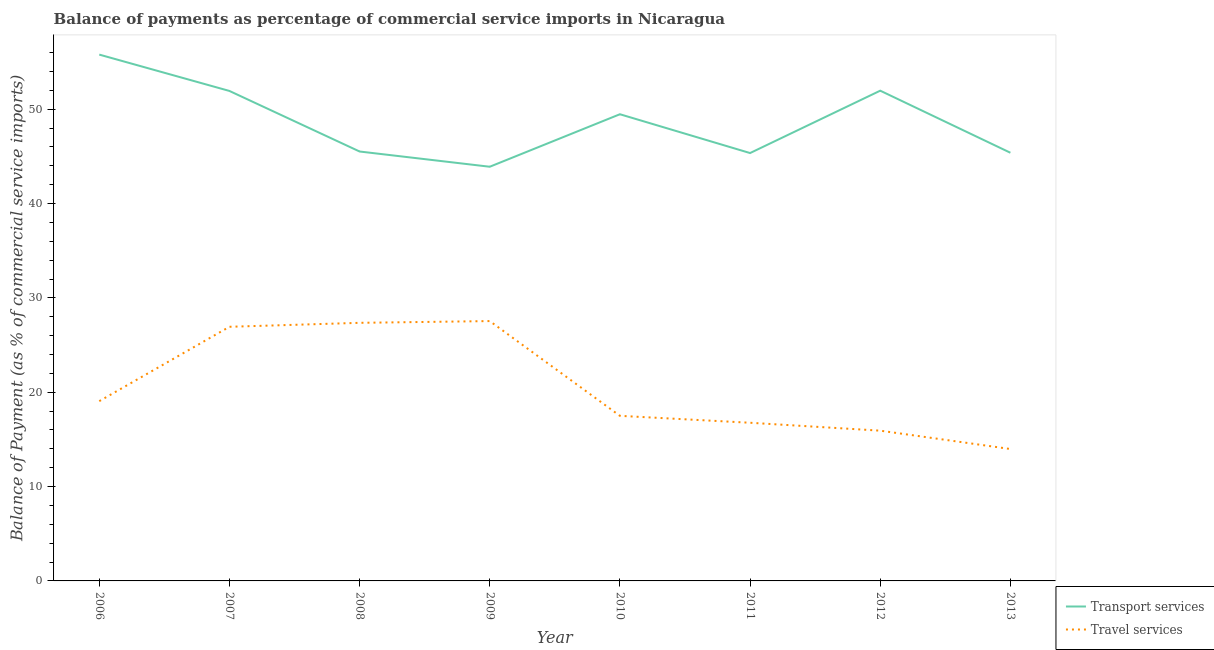How many different coloured lines are there?
Provide a short and direct response. 2. Is the number of lines equal to the number of legend labels?
Provide a succinct answer. Yes. What is the balance of payments of travel services in 2013?
Keep it short and to the point. 13.98. Across all years, what is the maximum balance of payments of transport services?
Your response must be concise. 55.78. Across all years, what is the minimum balance of payments of travel services?
Ensure brevity in your answer.  13.98. In which year was the balance of payments of travel services minimum?
Offer a terse response. 2013. What is the total balance of payments of transport services in the graph?
Provide a short and direct response. 389.28. What is the difference between the balance of payments of travel services in 2011 and that in 2013?
Provide a short and direct response. 2.78. What is the difference between the balance of payments of transport services in 2007 and the balance of payments of travel services in 2006?
Your answer should be very brief. 32.88. What is the average balance of payments of travel services per year?
Offer a very short reply. 20.63. In the year 2012, what is the difference between the balance of payments of travel services and balance of payments of transport services?
Keep it short and to the point. -36.03. What is the ratio of the balance of payments of transport services in 2009 to that in 2013?
Your response must be concise. 0.97. Is the difference between the balance of payments of transport services in 2008 and 2010 greater than the difference between the balance of payments of travel services in 2008 and 2010?
Keep it short and to the point. No. What is the difference between the highest and the second highest balance of payments of transport services?
Your answer should be very brief. 3.82. What is the difference between the highest and the lowest balance of payments of travel services?
Provide a short and direct response. 13.56. Is the sum of the balance of payments of travel services in 2009 and 2012 greater than the maximum balance of payments of transport services across all years?
Make the answer very short. No. Does the balance of payments of travel services monotonically increase over the years?
Offer a very short reply. No. How many years are there in the graph?
Your answer should be compact. 8. What is the difference between two consecutive major ticks on the Y-axis?
Offer a very short reply. 10. Does the graph contain any zero values?
Give a very brief answer. No. Does the graph contain grids?
Your answer should be very brief. No. How many legend labels are there?
Your response must be concise. 2. What is the title of the graph?
Offer a very short reply. Balance of payments as percentage of commercial service imports in Nicaragua. What is the label or title of the X-axis?
Keep it short and to the point. Year. What is the label or title of the Y-axis?
Your response must be concise. Balance of Payment (as % of commercial service imports). What is the Balance of Payment (as % of commercial service imports) of Transport services in 2006?
Ensure brevity in your answer.  55.78. What is the Balance of Payment (as % of commercial service imports) in Travel services in 2006?
Offer a terse response. 19.05. What is the Balance of Payment (as % of commercial service imports) of Transport services in 2007?
Offer a terse response. 51.93. What is the Balance of Payment (as % of commercial service imports) of Travel services in 2007?
Ensure brevity in your answer.  26.94. What is the Balance of Payment (as % of commercial service imports) in Transport services in 2008?
Make the answer very short. 45.51. What is the Balance of Payment (as % of commercial service imports) of Travel services in 2008?
Your response must be concise. 27.36. What is the Balance of Payment (as % of commercial service imports) of Transport services in 2009?
Offer a very short reply. 43.9. What is the Balance of Payment (as % of commercial service imports) of Travel services in 2009?
Your answer should be compact. 27.54. What is the Balance of Payment (as % of commercial service imports) of Transport services in 2010?
Give a very brief answer. 49.46. What is the Balance of Payment (as % of commercial service imports) of Travel services in 2010?
Ensure brevity in your answer.  17.5. What is the Balance of Payment (as % of commercial service imports) in Transport services in 2011?
Make the answer very short. 45.35. What is the Balance of Payment (as % of commercial service imports) in Travel services in 2011?
Give a very brief answer. 16.76. What is the Balance of Payment (as % of commercial service imports) in Transport services in 2012?
Your response must be concise. 51.96. What is the Balance of Payment (as % of commercial service imports) in Travel services in 2012?
Your response must be concise. 15.93. What is the Balance of Payment (as % of commercial service imports) of Transport services in 2013?
Provide a short and direct response. 45.38. What is the Balance of Payment (as % of commercial service imports) in Travel services in 2013?
Your response must be concise. 13.98. Across all years, what is the maximum Balance of Payment (as % of commercial service imports) of Transport services?
Your response must be concise. 55.78. Across all years, what is the maximum Balance of Payment (as % of commercial service imports) in Travel services?
Provide a short and direct response. 27.54. Across all years, what is the minimum Balance of Payment (as % of commercial service imports) of Transport services?
Your answer should be compact. 43.9. Across all years, what is the minimum Balance of Payment (as % of commercial service imports) of Travel services?
Give a very brief answer. 13.98. What is the total Balance of Payment (as % of commercial service imports) of Transport services in the graph?
Provide a short and direct response. 389.28. What is the total Balance of Payment (as % of commercial service imports) in Travel services in the graph?
Offer a terse response. 165.05. What is the difference between the Balance of Payment (as % of commercial service imports) of Transport services in 2006 and that in 2007?
Provide a short and direct response. 3.85. What is the difference between the Balance of Payment (as % of commercial service imports) in Travel services in 2006 and that in 2007?
Ensure brevity in your answer.  -7.88. What is the difference between the Balance of Payment (as % of commercial service imports) in Transport services in 2006 and that in 2008?
Your answer should be very brief. 10.27. What is the difference between the Balance of Payment (as % of commercial service imports) of Travel services in 2006 and that in 2008?
Give a very brief answer. -8.3. What is the difference between the Balance of Payment (as % of commercial service imports) of Transport services in 2006 and that in 2009?
Your answer should be compact. 11.89. What is the difference between the Balance of Payment (as % of commercial service imports) in Travel services in 2006 and that in 2009?
Offer a terse response. -8.49. What is the difference between the Balance of Payment (as % of commercial service imports) of Transport services in 2006 and that in 2010?
Your answer should be compact. 6.32. What is the difference between the Balance of Payment (as % of commercial service imports) of Travel services in 2006 and that in 2010?
Keep it short and to the point. 1.56. What is the difference between the Balance of Payment (as % of commercial service imports) of Transport services in 2006 and that in 2011?
Provide a short and direct response. 10.44. What is the difference between the Balance of Payment (as % of commercial service imports) in Travel services in 2006 and that in 2011?
Offer a terse response. 2.29. What is the difference between the Balance of Payment (as % of commercial service imports) of Transport services in 2006 and that in 2012?
Your answer should be very brief. 3.82. What is the difference between the Balance of Payment (as % of commercial service imports) in Travel services in 2006 and that in 2012?
Ensure brevity in your answer.  3.13. What is the difference between the Balance of Payment (as % of commercial service imports) in Transport services in 2006 and that in 2013?
Offer a terse response. 10.4. What is the difference between the Balance of Payment (as % of commercial service imports) in Travel services in 2006 and that in 2013?
Keep it short and to the point. 5.07. What is the difference between the Balance of Payment (as % of commercial service imports) in Transport services in 2007 and that in 2008?
Your answer should be very brief. 6.42. What is the difference between the Balance of Payment (as % of commercial service imports) in Travel services in 2007 and that in 2008?
Keep it short and to the point. -0.42. What is the difference between the Balance of Payment (as % of commercial service imports) in Transport services in 2007 and that in 2009?
Make the answer very short. 8.03. What is the difference between the Balance of Payment (as % of commercial service imports) in Travel services in 2007 and that in 2009?
Provide a succinct answer. -0.61. What is the difference between the Balance of Payment (as % of commercial service imports) in Transport services in 2007 and that in 2010?
Give a very brief answer. 2.47. What is the difference between the Balance of Payment (as % of commercial service imports) of Travel services in 2007 and that in 2010?
Provide a short and direct response. 9.44. What is the difference between the Balance of Payment (as % of commercial service imports) of Transport services in 2007 and that in 2011?
Offer a terse response. 6.58. What is the difference between the Balance of Payment (as % of commercial service imports) of Travel services in 2007 and that in 2011?
Ensure brevity in your answer.  10.17. What is the difference between the Balance of Payment (as % of commercial service imports) in Transport services in 2007 and that in 2012?
Make the answer very short. -0.03. What is the difference between the Balance of Payment (as % of commercial service imports) in Travel services in 2007 and that in 2012?
Give a very brief answer. 11.01. What is the difference between the Balance of Payment (as % of commercial service imports) in Transport services in 2007 and that in 2013?
Give a very brief answer. 6.55. What is the difference between the Balance of Payment (as % of commercial service imports) in Travel services in 2007 and that in 2013?
Your answer should be very brief. 12.95. What is the difference between the Balance of Payment (as % of commercial service imports) in Transport services in 2008 and that in 2009?
Keep it short and to the point. 1.62. What is the difference between the Balance of Payment (as % of commercial service imports) of Travel services in 2008 and that in 2009?
Offer a terse response. -0.19. What is the difference between the Balance of Payment (as % of commercial service imports) in Transport services in 2008 and that in 2010?
Provide a short and direct response. -3.95. What is the difference between the Balance of Payment (as % of commercial service imports) of Travel services in 2008 and that in 2010?
Give a very brief answer. 9.86. What is the difference between the Balance of Payment (as % of commercial service imports) of Transport services in 2008 and that in 2011?
Give a very brief answer. 0.16. What is the difference between the Balance of Payment (as % of commercial service imports) of Travel services in 2008 and that in 2011?
Your response must be concise. 10.59. What is the difference between the Balance of Payment (as % of commercial service imports) in Transport services in 2008 and that in 2012?
Your response must be concise. -6.45. What is the difference between the Balance of Payment (as % of commercial service imports) of Travel services in 2008 and that in 2012?
Make the answer very short. 11.43. What is the difference between the Balance of Payment (as % of commercial service imports) of Transport services in 2008 and that in 2013?
Your answer should be compact. 0.13. What is the difference between the Balance of Payment (as % of commercial service imports) of Travel services in 2008 and that in 2013?
Your response must be concise. 13.37. What is the difference between the Balance of Payment (as % of commercial service imports) of Transport services in 2009 and that in 2010?
Your answer should be very brief. -5.57. What is the difference between the Balance of Payment (as % of commercial service imports) of Travel services in 2009 and that in 2010?
Your answer should be very brief. 10.04. What is the difference between the Balance of Payment (as % of commercial service imports) in Transport services in 2009 and that in 2011?
Your answer should be very brief. -1.45. What is the difference between the Balance of Payment (as % of commercial service imports) of Travel services in 2009 and that in 2011?
Keep it short and to the point. 10.78. What is the difference between the Balance of Payment (as % of commercial service imports) in Transport services in 2009 and that in 2012?
Provide a short and direct response. -8.06. What is the difference between the Balance of Payment (as % of commercial service imports) of Travel services in 2009 and that in 2012?
Offer a very short reply. 11.62. What is the difference between the Balance of Payment (as % of commercial service imports) in Transport services in 2009 and that in 2013?
Ensure brevity in your answer.  -1.48. What is the difference between the Balance of Payment (as % of commercial service imports) in Travel services in 2009 and that in 2013?
Your response must be concise. 13.56. What is the difference between the Balance of Payment (as % of commercial service imports) of Transport services in 2010 and that in 2011?
Ensure brevity in your answer.  4.11. What is the difference between the Balance of Payment (as % of commercial service imports) of Travel services in 2010 and that in 2011?
Your answer should be very brief. 0.73. What is the difference between the Balance of Payment (as % of commercial service imports) of Transport services in 2010 and that in 2012?
Offer a very short reply. -2.5. What is the difference between the Balance of Payment (as % of commercial service imports) of Travel services in 2010 and that in 2012?
Make the answer very short. 1.57. What is the difference between the Balance of Payment (as % of commercial service imports) of Transport services in 2010 and that in 2013?
Offer a terse response. 4.08. What is the difference between the Balance of Payment (as % of commercial service imports) of Travel services in 2010 and that in 2013?
Offer a terse response. 3.52. What is the difference between the Balance of Payment (as % of commercial service imports) of Transport services in 2011 and that in 2012?
Keep it short and to the point. -6.61. What is the difference between the Balance of Payment (as % of commercial service imports) in Travel services in 2011 and that in 2012?
Make the answer very short. 0.84. What is the difference between the Balance of Payment (as % of commercial service imports) in Transport services in 2011 and that in 2013?
Provide a short and direct response. -0.03. What is the difference between the Balance of Payment (as % of commercial service imports) of Travel services in 2011 and that in 2013?
Provide a succinct answer. 2.78. What is the difference between the Balance of Payment (as % of commercial service imports) in Transport services in 2012 and that in 2013?
Offer a very short reply. 6.58. What is the difference between the Balance of Payment (as % of commercial service imports) of Travel services in 2012 and that in 2013?
Your response must be concise. 1.94. What is the difference between the Balance of Payment (as % of commercial service imports) of Transport services in 2006 and the Balance of Payment (as % of commercial service imports) of Travel services in 2007?
Ensure brevity in your answer.  28.85. What is the difference between the Balance of Payment (as % of commercial service imports) in Transport services in 2006 and the Balance of Payment (as % of commercial service imports) in Travel services in 2008?
Offer a terse response. 28.43. What is the difference between the Balance of Payment (as % of commercial service imports) in Transport services in 2006 and the Balance of Payment (as % of commercial service imports) in Travel services in 2009?
Keep it short and to the point. 28.24. What is the difference between the Balance of Payment (as % of commercial service imports) of Transport services in 2006 and the Balance of Payment (as % of commercial service imports) of Travel services in 2010?
Give a very brief answer. 38.29. What is the difference between the Balance of Payment (as % of commercial service imports) in Transport services in 2006 and the Balance of Payment (as % of commercial service imports) in Travel services in 2011?
Your answer should be compact. 39.02. What is the difference between the Balance of Payment (as % of commercial service imports) of Transport services in 2006 and the Balance of Payment (as % of commercial service imports) of Travel services in 2012?
Provide a succinct answer. 39.86. What is the difference between the Balance of Payment (as % of commercial service imports) of Transport services in 2006 and the Balance of Payment (as % of commercial service imports) of Travel services in 2013?
Offer a very short reply. 41.8. What is the difference between the Balance of Payment (as % of commercial service imports) in Transport services in 2007 and the Balance of Payment (as % of commercial service imports) in Travel services in 2008?
Your answer should be compact. 24.58. What is the difference between the Balance of Payment (as % of commercial service imports) in Transport services in 2007 and the Balance of Payment (as % of commercial service imports) in Travel services in 2009?
Your answer should be compact. 24.39. What is the difference between the Balance of Payment (as % of commercial service imports) of Transport services in 2007 and the Balance of Payment (as % of commercial service imports) of Travel services in 2010?
Your answer should be compact. 34.43. What is the difference between the Balance of Payment (as % of commercial service imports) in Transport services in 2007 and the Balance of Payment (as % of commercial service imports) in Travel services in 2011?
Ensure brevity in your answer.  35.17. What is the difference between the Balance of Payment (as % of commercial service imports) in Transport services in 2007 and the Balance of Payment (as % of commercial service imports) in Travel services in 2012?
Give a very brief answer. 36.01. What is the difference between the Balance of Payment (as % of commercial service imports) in Transport services in 2007 and the Balance of Payment (as % of commercial service imports) in Travel services in 2013?
Provide a short and direct response. 37.95. What is the difference between the Balance of Payment (as % of commercial service imports) of Transport services in 2008 and the Balance of Payment (as % of commercial service imports) of Travel services in 2009?
Your answer should be compact. 17.97. What is the difference between the Balance of Payment (as % of commercial service imports) in Transport services in 2008 and the Balance of Payment (as % of commercial service imports) in Travel services in 2010?
Make the answer very short. 28.02. What is the difference between the Balance of Payment (as % of commercial service imports) in Transport services in 2008 and the Balance of Payment (as % of commercial service imports) in Travel services in 2011?
Your answer should be very brief. 28.75. What is the difference between the Balance of Payment (as % of commercial service imports) in Transport services in 2008 and the Balance of Payment (as % of commercial service imports) in Travel services in 2012?
Give a very brief answer. 29.59. What is the difference between the Balance of Payment (as % of commercial service imports) of Transport services in 2008 and the Balance of Payment (as % of commercial service imports) of Travel services in 2013?
Ensure brevity in your answer.  31.53. What is the difference between the Balance of Payment (as % of commercial service imports) of Transport services in 2009 and the Balance of Payment (as % of commercial service imports) of Travel services in 2010?
Give a very brief answer. 26.4. What is the difference between the Balance of Payment (as % of commercial service imports) of Transport services in 2009 and the Balance of Payment (as % of commercial service imports) of Travel services in 2011?
Make the answer very short. 27.13. What is the difference between the Balance of Payment (as % of commercial service imports) of Transport services in 2009 and the Balance of Payment (as % of commercial service imports) of Travel services in 2012?
Your answer should be compact. 27.97. What is the difference between the Balance of Payment (as % of commercial service imports) of Transport services in 2009 and the Balance of Payment (as % of commercial service imports) of Travel services in 2013?
Provide a short and direct response. 29.92. What is the difference between the Balance of Payment (as % of commercial service imports) in Transport services in 2010 and the Balance of Payment (as % of commercial service imports) in Travel services in 2011?
Give a very brief answer. 32.7. What is the difference between the Balance of Payment (as % of commercial service imports) of Transport services in 2010 and the Balance of Payment (as % of commercial service imports) of Travel services in 2012?
Provide a short and direct response. 33.54. What is the difference between the Balance of Payment (as % of commercial service imports) in Transport services in 2010 and the Balance of Payment (as % of commercial service imports) in Travel services in 2013?
Provide a succinct answer. 35.48. What is the difference between the Balance of Payment (as % of commercial service imports) in Transport services in 2011 and the Balance of Payment (as % of commercial service imports) in Travel services in 2012?
Your answer should be compact. 29.42. What is the difference between the Balance of Payment (as % of commercial service imports) of Transport services in 2011 and the Balance of Payment (as % of commercial service imports) of Travel services in 2013?
Your answer should be very brief. 31.37. What is the difference between the Balance of Payment (as % of commercial service imports) of Transport services in 2012 and the Balance of Payment (as % of commercial service imports) of Travel services in 2013?
Offer a very short reply. 37.98. What is the average Balance of Payment (as % of commercial service imports) in Transport services per year?
Your answer should be compact. 48.66. What is the average Balance of Payment (as % of commercial service imports) of Travel services per year?
Ensure brevity in your answer.  20.63. In the year 2006, what is the difference between the Balance of Payment (as % of commercial service imports) in Transport services and Balance of Payment (as % of commercial service imports) in Travel services?
Your response must be concise. 36.73. In the year 2007, what is the difference between the Balance of Payment (as % of commercial service imports) in Transport services and Balance of Payment (as % of commercial service imports) in Travel services?
Your response must be concise. 25. In the year 2008, what is the difference between the Balance of Payment (as % of commercial service imports) of Transport services and Balance of Payment (as % of commercial service imports) of Travel services?
Provide a succinct answer. 18.16. In the year 2009, what is the difference between the Balance of Payment (as % of commercial service imports) in Transport services and Balance of Payment (as % of commercial service imports) in Travel services?
Offer a very short reply. 16.36. In the year 2010, what is the difference between the Balance of Payment (as % of commercial service imports) of Transport services and Balance of Payment (as % of commercial service imports) of Travel services?
Give a very brief answer. 31.97. In the year 2011, what is the difference between the Balance of Payment (as % of commercial service imports) of Transport services and Balance of Payment (as % of commercial service imports) of Travel services?
Your answer should be very brief. 28.59. In the year 2012, what is the difference between the Balance of Payment (as % of commercial service imports) of Transport services and Balance of Payment (as % of commercial service imports) of Travel services?
Give a very brief answer. 36.03. In the year 2013, what is the difference between the Balance of Payment (as % of commercial service imports) of Transport services and Balance of Payment (as % of commercial service imports) of Travel services?
Keep it short and to the point. 31.4. What is the ratio of the Balance of Payment (as % of commercial service imports) of Transport services in 2006 to that in 2007?
Offer a very short reply. 1.07. What is the ratio of the Balance of Payment (as % of commercial service imports) of Travel services in 2006 to that in 2007?
Give a very brief answer. 0.71. What is the ratio of the Balance of Payment (as % of commercial service imports) of Transport services in 2006 to that in 2008?
Give a very brief answer. 1.23. What is the ratio of the Balance of Payment (as % of commercial service imports) of Travel services in 2006 to that in 2008?
Ensure brevity in your answer.  0.7. What is the ratio of the Balance of Payment (as % of commercial service imports) in Transport services in 2006 to that in 2009?
Offer a very short reply. 1.27. What is the ratio of the Balance of Payment (as % of commercial service imports) in Travel services in 2006 to that in 2009?
Your response must be concise. 0.69. What is the ratio of the Balance of Payment (as % of commercial service imports) in Transport services in 2006 to that in 2010?
Offer a very short reply. 1.13. What is the ratio of the Balance of Payment (as % of commercial service imports) of Travel services in 2006 to that in 2010?
Keep it short and to the point. 1.09. What is the ratio of the Balance of Payment (as % of commercial service imports) of Transport services in 2006 to that in 2011?
Give a very brief answer. 1.23. What is the ratio of the Balance of Payment (as % of commercial service imports) in Travel services in 2006 to that in 2011?
Make the answer very short. 1.14. What is the ratio of the Balance of Payment (as % of commercial service imports) in Transport services in 2006 to that in 2012?
Offer a very short reply. 1.07. What is the ratio of the Balance of Payment (as % of commercial service imports) of Travel services in 2006 to that in 2012?
Your response must be concise. 1.2. What is the ratio of the Balance of Payment (as % of commercial service imports) in Transport services in 2006 to that in 2013?
Make the answer very short. 1.23. What is the ratio of the Balance of Payment (as % of commercial service imports) in Travel services in 2006 to that in 2013?
Your answer should be compact. 1.36. What is the ratio of the Balance of Payment (as % of commercial service imports) of Transport services in 2007 to that in 2008?
Offer a terse response. 1.14. What is the ratio of the Balance of Payment (as % of commercial service imports) of Travel services in 2007 to that in 2008?
Keep it short and to the point. 0.98. What is the ratio of the Balance of Payment (as % of commercial service imports) of Transport services in 2007 to that in 2009?
Your response must be concise. 1.18. What is the ratio of the Balance of Payment (as % of commercial service imports) in Transport services in 2007 to that in 2010?
Offer a very short reply. 1.05. What is the ratio of the Balance of Payment (as % of commercial service imports) of Travel services in 2007 to that in 2010?
Ensure brevity in your answer.  1.54. What is the ratio of the Balance of Payment (as % of commercial service imports) of Transport services in 2007 to that in 2011?
Give a very brief answer. 1.15. What is the ratio of the Balance of Payment (as % of commercial service imports) of Travel services in 2007 to that in 2011?
Keep it short and to the point. 1.61. What is the ratio of the Balance of Payment (as % of commercial service imports) in Travel services in 2007 to that in 2012?
Your answer should be compact. 1.69. What is the ratio of the Balance of Payment (as % of commercial service imports) of Transport services in 2007 to that in 2013?
Provide a succinct answer. 1.14. What is the ratio of the Balance of Payment (as % of commercial service imports) in Travel services in 2007 to that in 2013?
Offer a very short reply. 1.93. What is the ratio of the Balance of Payment (as % of commercial service imports) of Transport services in 2008 to that in 2009?
Ensure brevity in your answer.  1.04. What is the ratio of the Balance of Payment (as % of commercial service imports) in Transport services in 2008 to that in 2010?
Your response must be concise. 0.92. What is the ratio of the Balance of Payment (as % of commercial service imports) in Travel services in 2008 to that in 2010?
Give a very brief answer. 1.56. What is the ratio of the Balance of Payment (as % of commercial service imports) in Travel services in 2008 to that in 2011?
Give a very brief answer. 1.63. What is the ratio of the Balance of Payment (as % of commercial service imports) of Transport services in 2008 to that in 2012?
Your answer should be compact. 0.88. What is the ratio of the Balance of Payment (as % of commercial service imports) of Travel services in 2008 to that in 2012?
Make the answer very short. 1.72. What is the ratio of the Balance of Payment (as % of commercial service imports) in Transport services in 2008 to that in 2013?
Ensure brevity in your answer.  1. What is the ratio of the Balance of Payment (as % of commercial service imports) of Travel services in 2008 to that in 2013?
Offer a very short reply. 1.96. What is the ratio of the Balance of Payment (as % of commercial service imports) in Transport services in 2009 to that in 2010?
Make the answer very short. 0.89. What is the ratio of the Balance of Payment (as % of commercial service imports) of Travel services in 2009 to that in 2010?
Your response must be concise. 1.57. What is the ratio of the Balance of Payment (as % of commercial service imports) in Transport services in 2009 to that in 2011?
Offer a very short reply. 0.97. What is the ratio of the Balance of Payment (as % of commercial service imports) in Travel services in 2009 to that in 2011?
Keep it short and to the point. 1.64. What is the ratio of the Balance of Payment (as % of commercial service imports) of Transport services in 2009 to that in 2012?
Your answer should be compact. 0.84. What is the ratio of the Balance of Payment (as % of commercial service imports) in Travel services in 2009 to that in 2012?
Offer a very short reply. 1.73. What is the ratio of the Balance of Payment (as % of commercial service imports) of Transport services in 2009 to that in 2013?
Offer a terse response. 0.97. What is the ratio of the Balance of Payment (as % of commercial service imports) of Travel services in 2009 to that in 2013?
Your answer should be very brief. 1.97. What is the ratio of the Balance of Payment (as % of commercial service imports) in Transport services in 2010 to that in 2011?
Keep it short and to the point. 1.09. What is the ratio of the Balance of Payment (as % of commercial service imports) in Travel services in 2010 to that in 2011?
Offer a terse response. 1.04. What is the ratio of the Balance of Payment (as % of commercial service imports) in Transport services in 2010 to that in 2012?
Make the answer very short. 0.95. What is the ratio of the Balance of Payment (as % of commercial service imports) in Travel services in 2010 to that in 2012?
Offer a terse response. 1.1. What is the ratio of the Balance of Payment (as % of commercial service imports) of Transport services in 2010 to that in 2013?
Ensure brevity in your answer.  1.09. What is the ratio of the Balance of Payment (as % of commercial service imports) of Travel services in 2010 to that in 2013?
Your response must be concise. 1.25. What is the ratio of the Balance of Payment (as % of commercial service imports) of Transport services in 2011 to that in 2012?
Keep it short and to the point. 0.87. What is the ratio of the Balance of Payment (as % of commercial service imports) of Travel services in 2011 to that in 2012?
Ensure brevity in your answer.  1.05. What is the ratio of the Balance of Payment (as % of commercial service imports) in Transport services in 2011 to that in 2013?
Your answer should be very brief. 1. What is the ratio of the Balance of Payment (as % of commercial service imports) in Travel services in 2011 to that in 2013?
Provide a short and direct response. 1.2. What is the ratio of the Balance of Payment (as % of commercial service imports) in Transport services in 2012 to that in 2013?
Your answer should be very brief. 1.15. What is the ratio of the Balance of Payment (as % of commercial service imports) of Travel services in 2012 to that in 2013?
Offer a terse response. 1.14. What is the difference between the highest and the second highest Balance of Payment (as % of commercial service imports) of Transport services?
Provide a short and direct response. 3.82. What is the difference between the highest and the second highest Balance of Payment (as % of commercial service imports) in Travel services?
Provide a succinct answer. 0.19. What is the difference between the highest and the lowest Balance of Payment (as % of commercial service imports) in Transport services?
Your answer should be compact. 11.89. What is the difference between the highest and the lowest Balance of Payment (as % of commercial service imports) in Travel services?
Your answer should be compact. 13.56. 